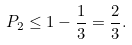<formula> <loc_0><loc_0><loc_500><loc_500>P _ { 2 } \leq 1 - \frac { 1 } { 3 } = \frac { 2 } { 3 } .</formula> 